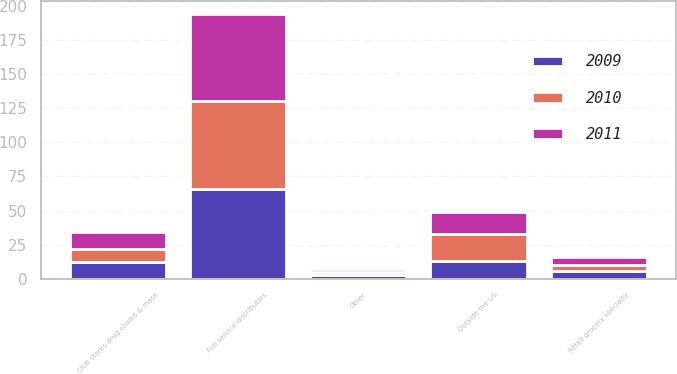Convert chart to OTSL. <chart><loc_0><loc_0><loc_500><loc_500><stacked_bar_chart><ecel><fcel>Full service distributors<fcel>Club stores drug chains & mass<fcel>Outside the US<fcel>Retail grocery specialty<fcel>Other<nl><fcel>2010<fcel>64<fcel>10<fcel>20<fcel>4<fcel>2<nl><fcel>2011<fcel>64<fcel>12<fcel>16<fcel>6<fcel>2<nl><fcel>2009<fcel>66<fcel>12<fcel>13<fcel>6<fcel>3<nl></chart> 